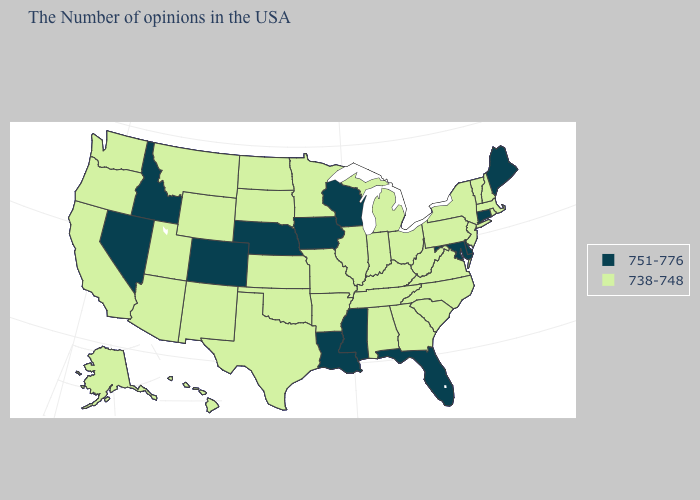Which states have the lowest value in the USA?
Answer briefly. Massachusetts, Rhode Island, New Hampshire, Vermont, New York, New Jersey, Pennsylvania, Virginia, North Carolina, South Carolina, West Virginia, Ohio, Georgia, Michigan, Kentucky, Indiana, Alabama, Tennessee, Illinois, Missouri, Arkansas, Minnesota, Kansas, Oklahoma, Texas, South Dakota, North Dakota, Wyoming, New Mexico, Utah, Montana, Arizona, California, Washington, Oregon, Alaska, Hawaii. Does the map have missing data?
Keep it brief. No. Which states have the lowest value in the USA?
Keep it brief. Massachusetts, Rhode Island, New Hampshire, Vermont, New York, New Jersey, Pennsylvania, Virginia, North Carolina, South Carolina, West Virginia, Ohio, Georgia, Michigan, Kentucky, Indiana, Alabama, Tennessee, Illinois, Missouri, Arkansas, Minnesota, Kansas, Oklahoma, Texas, South Dakota, North Dakota, Wyoming, New Mexico, Utah, Montana, Arizona, California, Washington, Oregon, Alaska, Hawaii. What is the value of Kentucky?
Concise answer only. 738-748. Among the states that border Delaware , does Maryland have the lowest value?
Short answer required. No. Which states have the lowest value in the USA?
Short answer required. Massachusetts, Rhode Island, New Hampshire, Vermont, New York, New Jersey, Pennsylvania, Virginia, North Carolina, South Carolina, West Virginia, Ohio, Georgia, Michigan, Kentucky, Indiana, Alabama, Tennessee, Illinois, Missouri, Arkansas, Minnesota, Kansas, Oklahoma, Texas, South Dakota, North Dakota, Wyoming, New Mexico, Utah, Montana, Arizona, California, Washington, Oregon, Alaska, Hawaii. Name the states that have a value in the range 738-748?
Keep it brief. Massachusetts, Rhode Island, New Hampshire, Vermont, New York, New Jersey, Pennsylvania, Virginia, North Carolina, South Carolina, West Virginia, Ohio, Georgia, Michigan, Kentucky, Indiana, Alabama, Tennessee, Illinois, Missouri, Arkansas, Minnesota, Kansas, Oklahoma, Texas, South Dakota, North Dakota, Wyoming, New Mexico, Utah, Montana, Arizona, California, Washington, Oregon, Alaska, Hawaii. What is the value of Ohio?
Be succinct. 738-748. What is the value of Texas?
Be succinct. 738-748. What is the value of New Mexico?
Keep it brief. 738-748. What is the value of Kansas?
Give a very brief answer. 738-748. Which states have the lowest value in the USA?
Keep it brief. Massachusetts, Rhode Island, New Hampshire, Vermont, New York, New Jersey, Pennsylvania, Virginia, North Carolina, South Carolina, West Virginia, Ohio, Georgia, Michigan, Kentucky, Indiana, Alabama, Tennessee, Illinois, Missouri, Arkansas, Minnesota, Kansas, Oklahoma, Texas, South Dakota, North Dakota, Wyoming, New Mexico, Utah, Montana, Arizona, California, Washington, Oregon, Alaska, Hawaii. What is the lowest value in the USA?
Short answer required. 738-748. Does Alaska have the lowest value in the USA?
Keep it brief. Yes. Which states have the highest value in the USA?
Give a very brief answer. Maine, Connecticut, Delaware, Maryland, Florida, Wisconsin, Mississippi, Louisiana, Iowa, Nebraska, Colorado, Idaho, Nevada. 